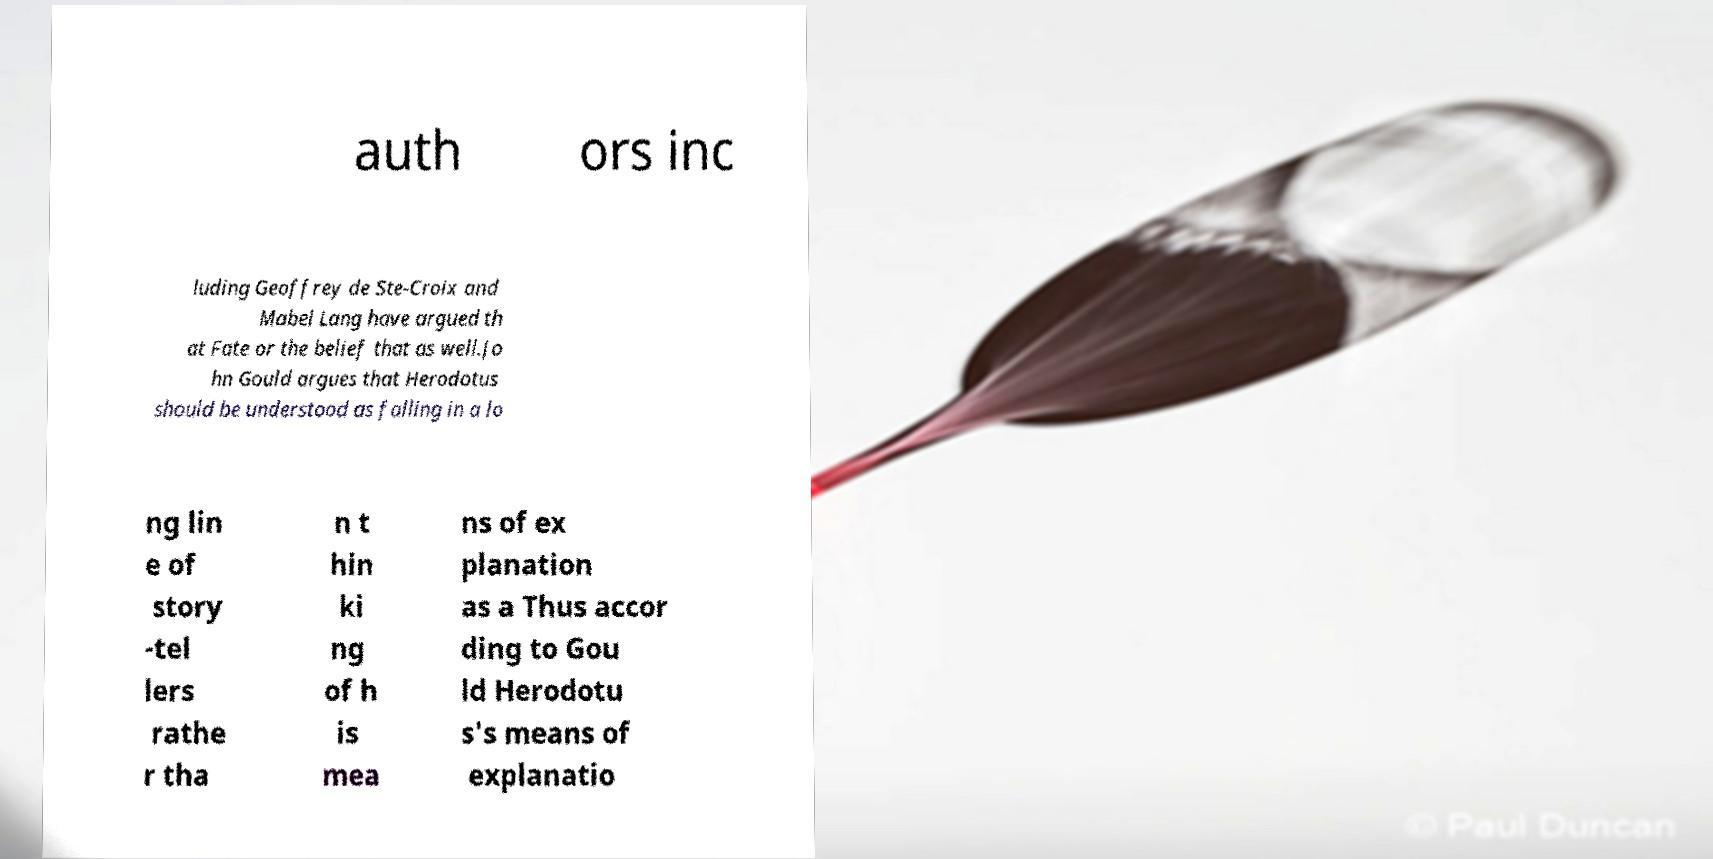Can you read and provide the text displayed in the image?This photo seems to have some interesting text. Can you extract and type it out for me? auth ors inc luding Geoffrey de Ste-Croix and Mabel Lang have argued th at Fate or the belief that as well.Jo hn Gould argues that Herodotus should be understood as falling in a lo ng lin e of story -tel lers rathe r tha n t hin ki ng of h is mea ns of ex planation as a Thus accor ding to Gou ld Herodotu s's means of explanatio 